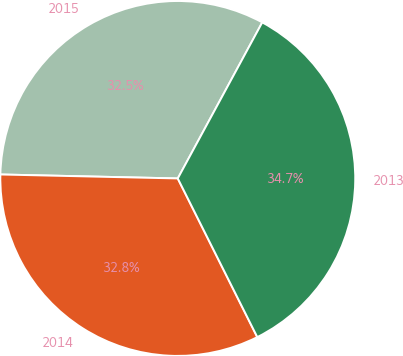Convert chart. <chart><loc_0><loc_0><loc_500><loc_500><pie_chart><fcel>2015<fcel>2014<fcel>2013<nl><fcel>32.54%<fcel>32.75%<fcel>34.71%<nl></chart> 